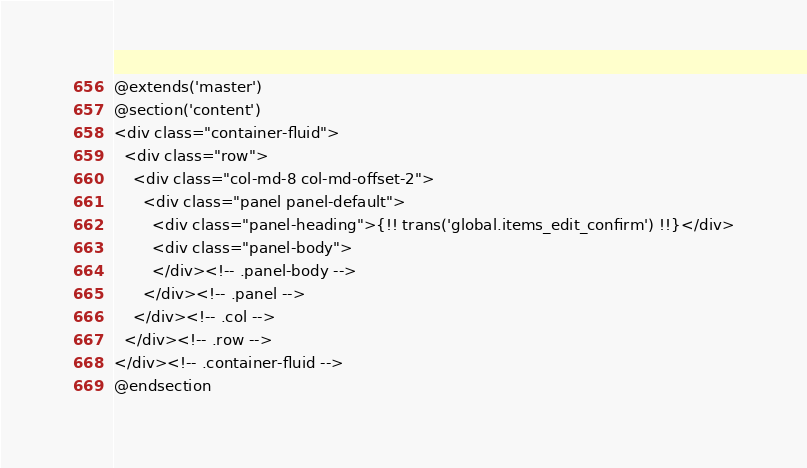<code> <loc_0><loc_0><loc_500><loc_500><_PHP_>@extends('master')
@section('content')
<div class="container-fluid">
  <div class="row">
    <div class="col-md-8 col-md-offset-2">
      <div class="panel panel-default">
        <div class="panel-heading">{!! trans('global.items_edit_confirm') !!}</div>
        <div class="panel-body">
        </div><!-- .panel-body -->
      </div><!-- .panel -->
    </div><!-- .col -->
  </div><!-- .row -->
</div><!-- .container-fluid -->
@endsection</code> 